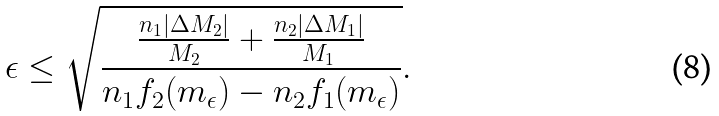Convert formula to latex. <formula><loc_0><loc_0><loc_500><loc_500>\epsilon \leq \sqrt { \frac { \frac { n _ { 1 } | \Delta M _ { 2 } | } { M _ { 2 } } + \frac { n _ { 2 } | \Delta M _ { 1 } | } { M _ { 1 } } } { n _ { 1 } f _ { 2 } ( m _ { \epsilon } ) - n _ { 2 } f _ { 1 } ( m _ { \epsilon } ) } } .</formula> 